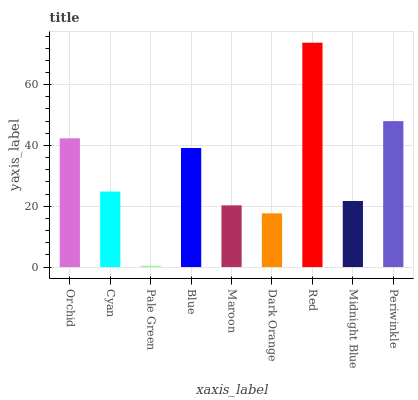Is Pale Green the minimum?
Answer yes or no. Yes. Is Red the maximum?
Answer yes or no. Yes. Is Cyan the minimum?
Answer yes or no. No. Is Cyan the maximum?
Answer yes or no. No. Is Orchid greater than Cyan?
Answer yes or no. Yes. Is Cyan less than Orchid?
Answer yes or no. Yes. Is Cyan greater than Orchid?
Answer yes or no. No. Is Orchid less than Cyan?
Answer yes or no. No. Is Cyan the high median?
Answer yes or no. Yes. Is Cyan the low median?
Answer yes or no. Yes. Is Maroon the high median?
Answer yes or no. No. Is Maroon the low median?
Answer yes or no. No. 